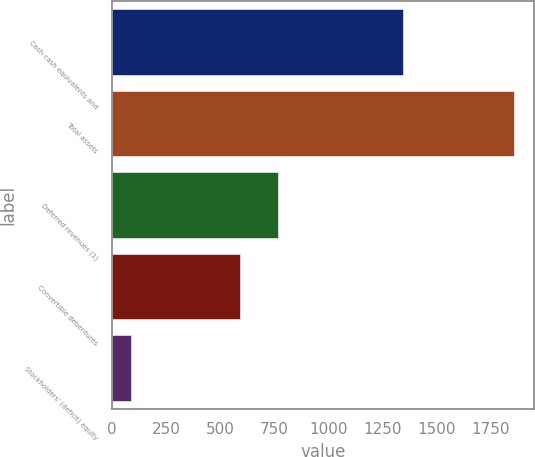Convert chart to OTSL. <chart><loc_0><loc_0><loc_500><loc_500><bar_chart><fcel>Cash cash equivalents and<fcel>Total assets<fcel>Deferred revenues (1)<fcel>Convertible debentures<fcel>Stockholders' (deficit) equity<nl><fcel>1346<fcel>1856<fcel>766.8<fcel>590<fcel>88<nl></chart> 